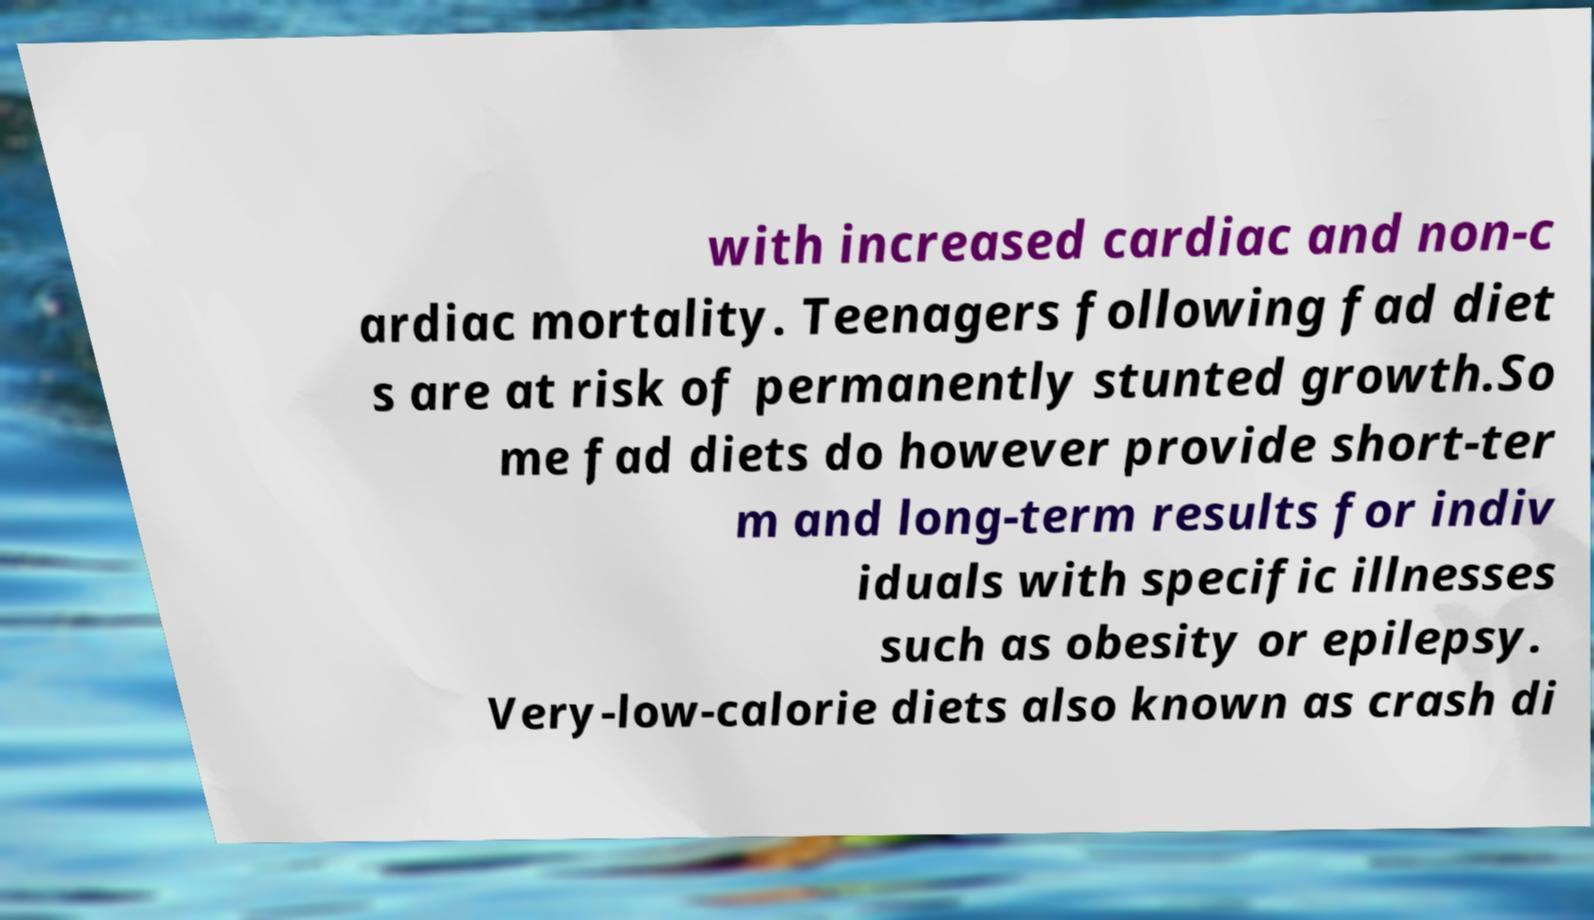What messages or text are displayed in this image? I need them in a readable, typed format. with increased cardiac and non-c ardiac mortality. Teenagers following fad diet s are at risk of permanently stunted growth.So me fad diets do however provide short-ter m and long-term results for indiv iduals with specific illnesses such as obesity or epilepsy. Very-low-calorie diets also known as crash di 